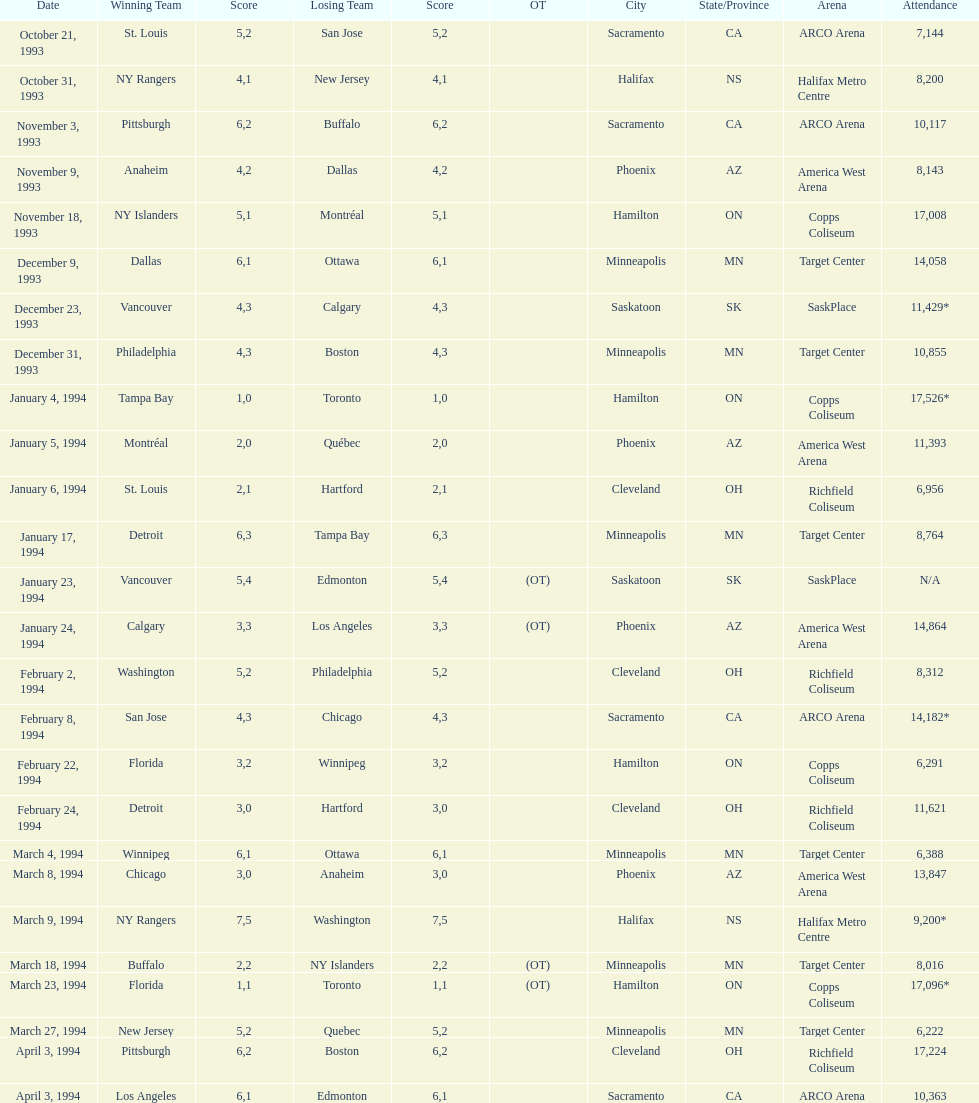Did dallas or ottawa win the december 9, 1993 game? Dallas. 